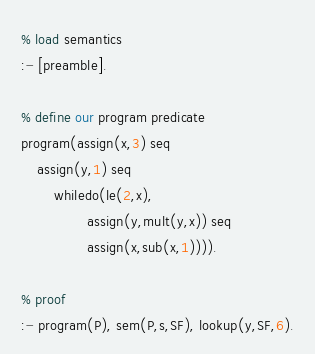<code> <loc_0><loc_0><loc_500><loc_500><_Perl_>% load semantics
:- [preamble].

% define our program predicate
program(assign(x,3) seq 
	assign(y,1) seq 
        whiledo(le(2,x),
                assign(y,mult(y,x)) seq 
                assign(x,sub(x,1)))).

% proof
:- program(P), sem(P,s,SF), lookup(y,SF,6).
</code> 